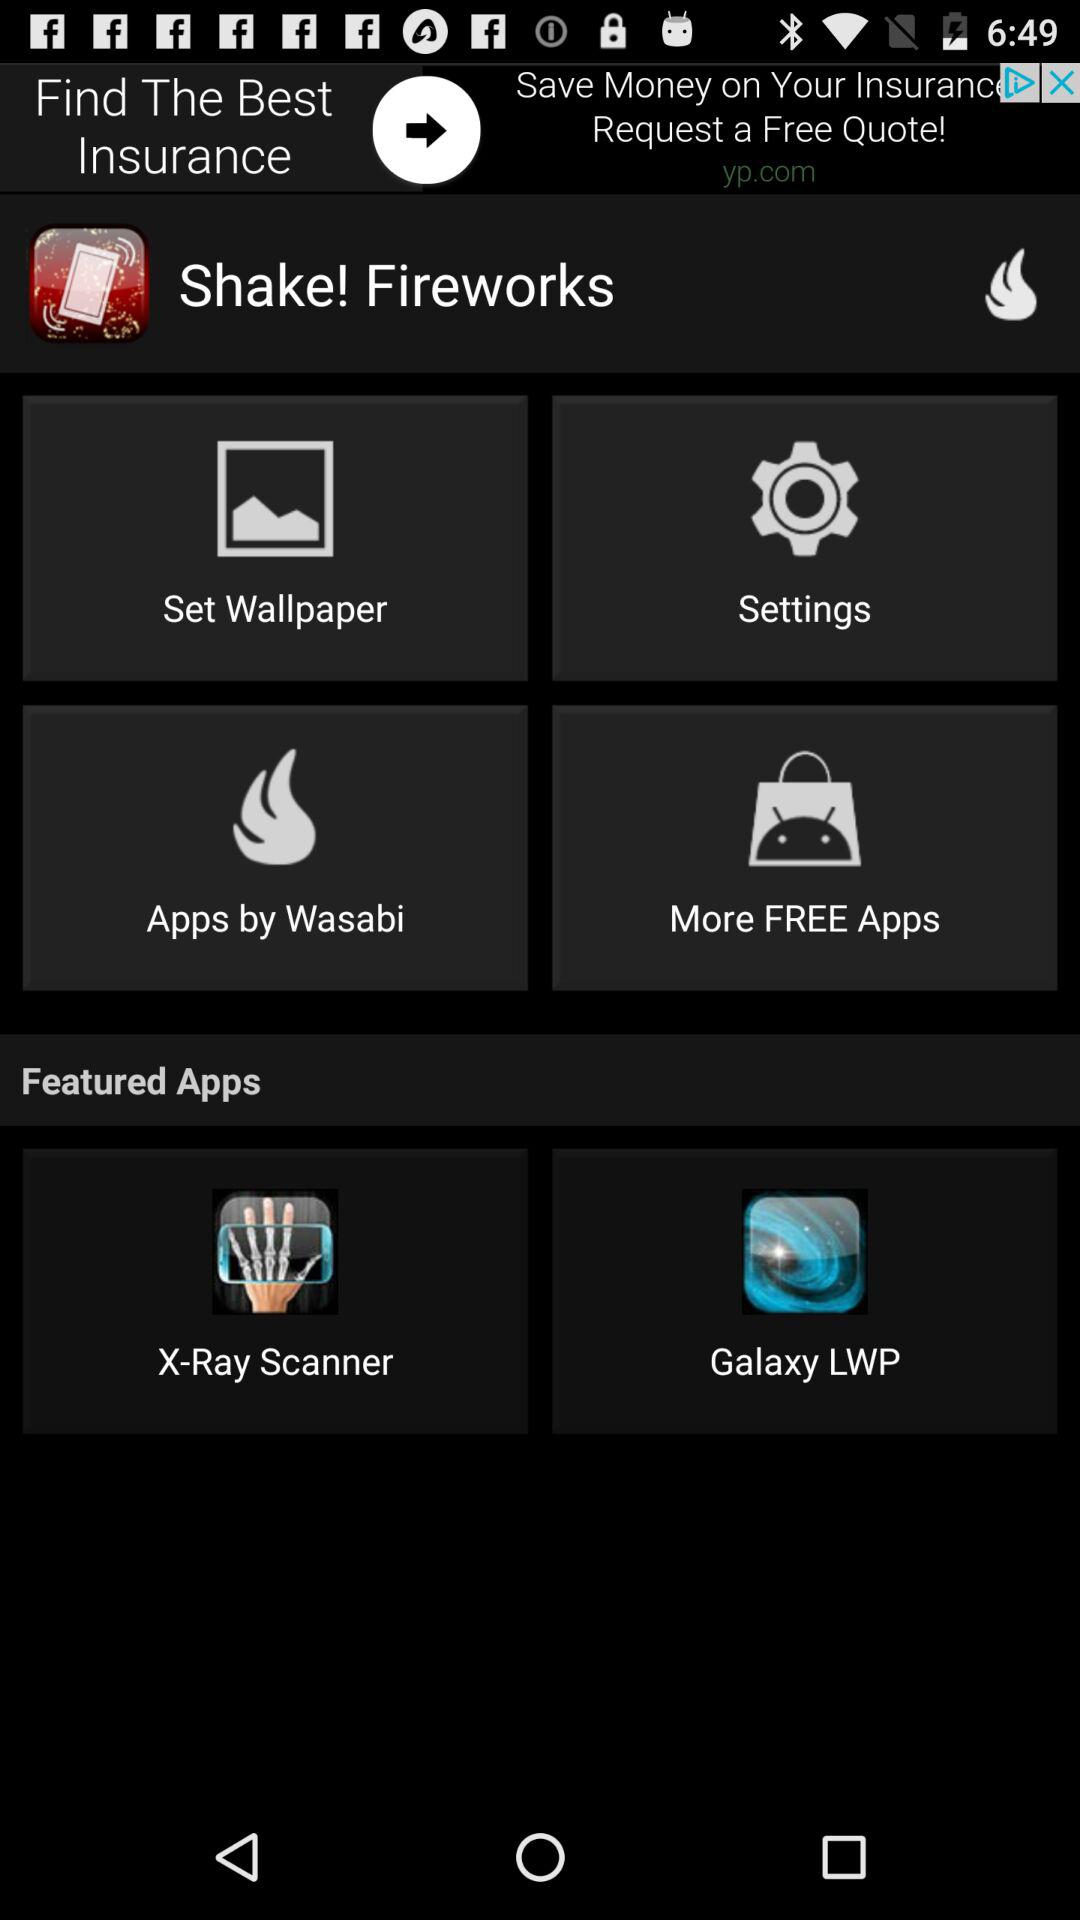How many notifications are there in "Settings"?
When the provided information is insufficient, respond with <no answer>. <no answer> 